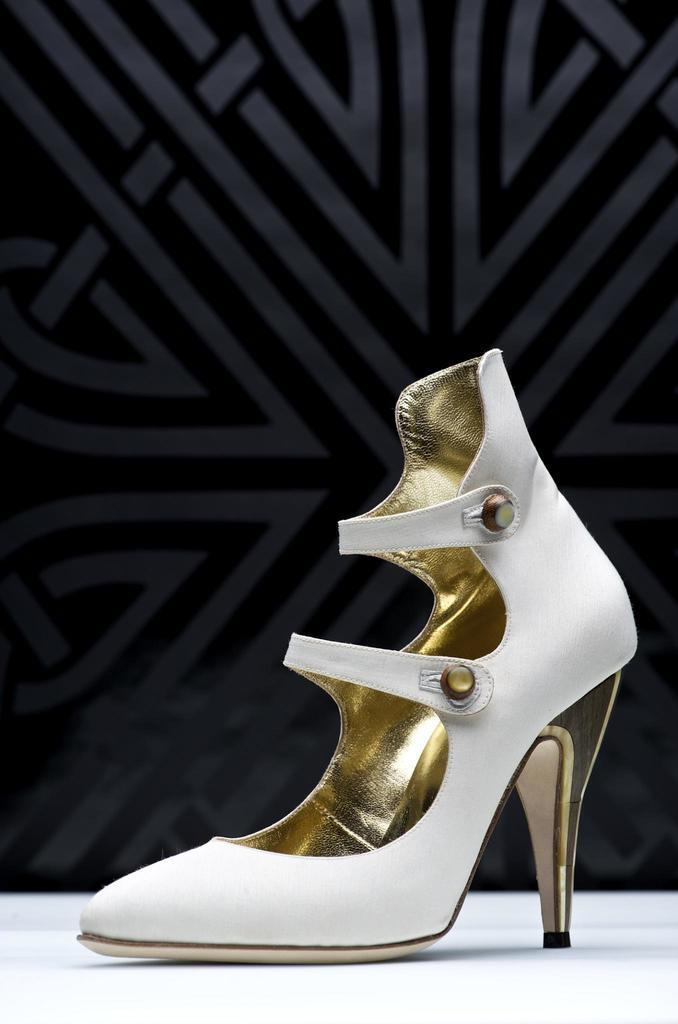What is the color of the surface in the image? The surface in the image is white in color. What can be seen on the surface? There is a white and golden heel on the surface. What type of ball is being used to play a game in the image? There is no ball present in the image; it features a white surface with a white and golden heel on it. 